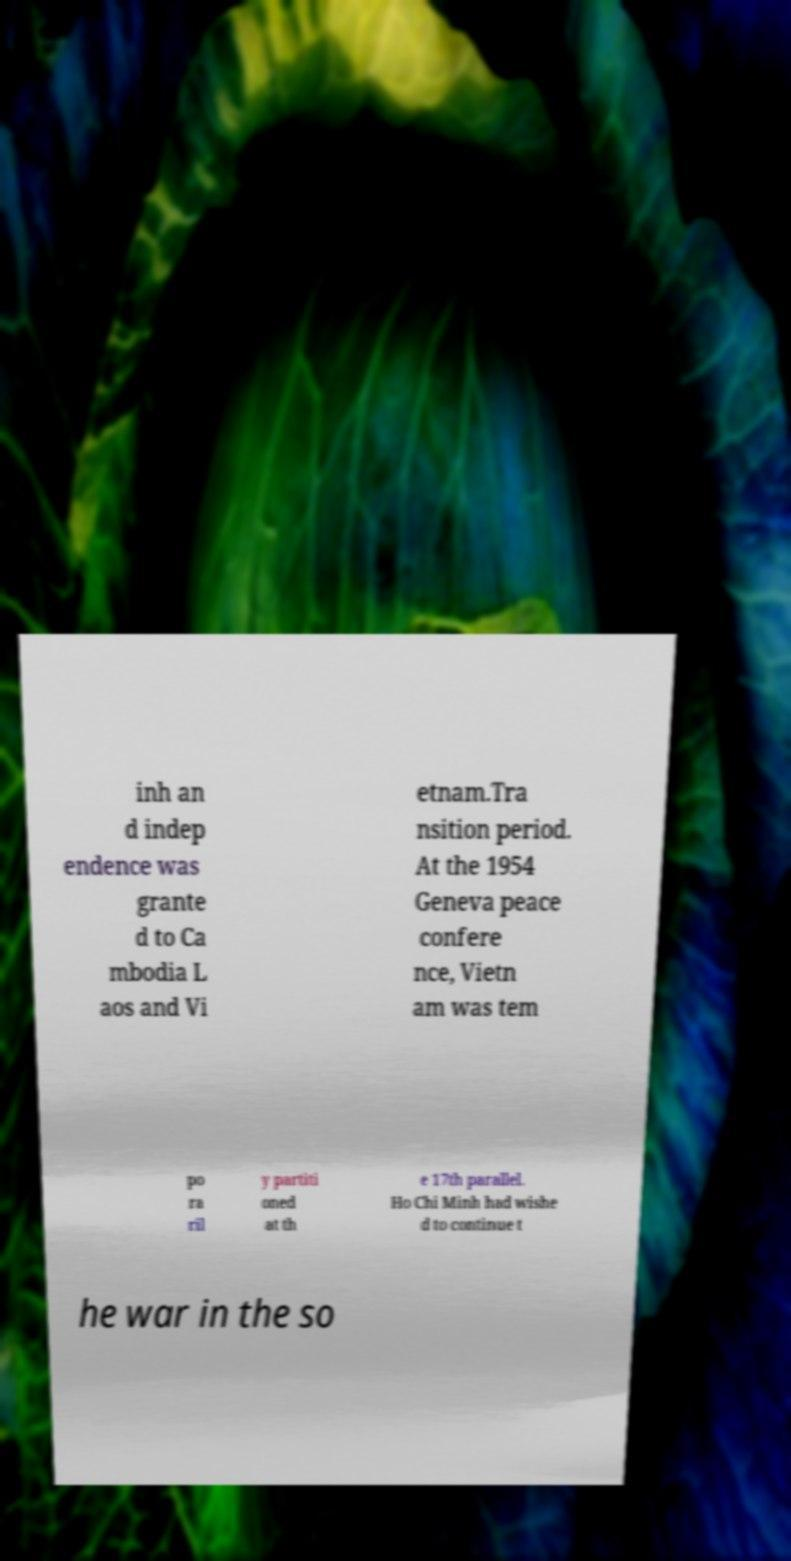Please identify and transcribe the text found in this image. inh an d indep endence was grante d to Ca mbodia L aos and Vi etnam.Tra nsition period. At the 1954 Geneva peace confere nce, Vietn am was tem po ra ril y partiti oned at th e 17th parallel. Ho Chi Minh had wishe d to continue t he war in the so 